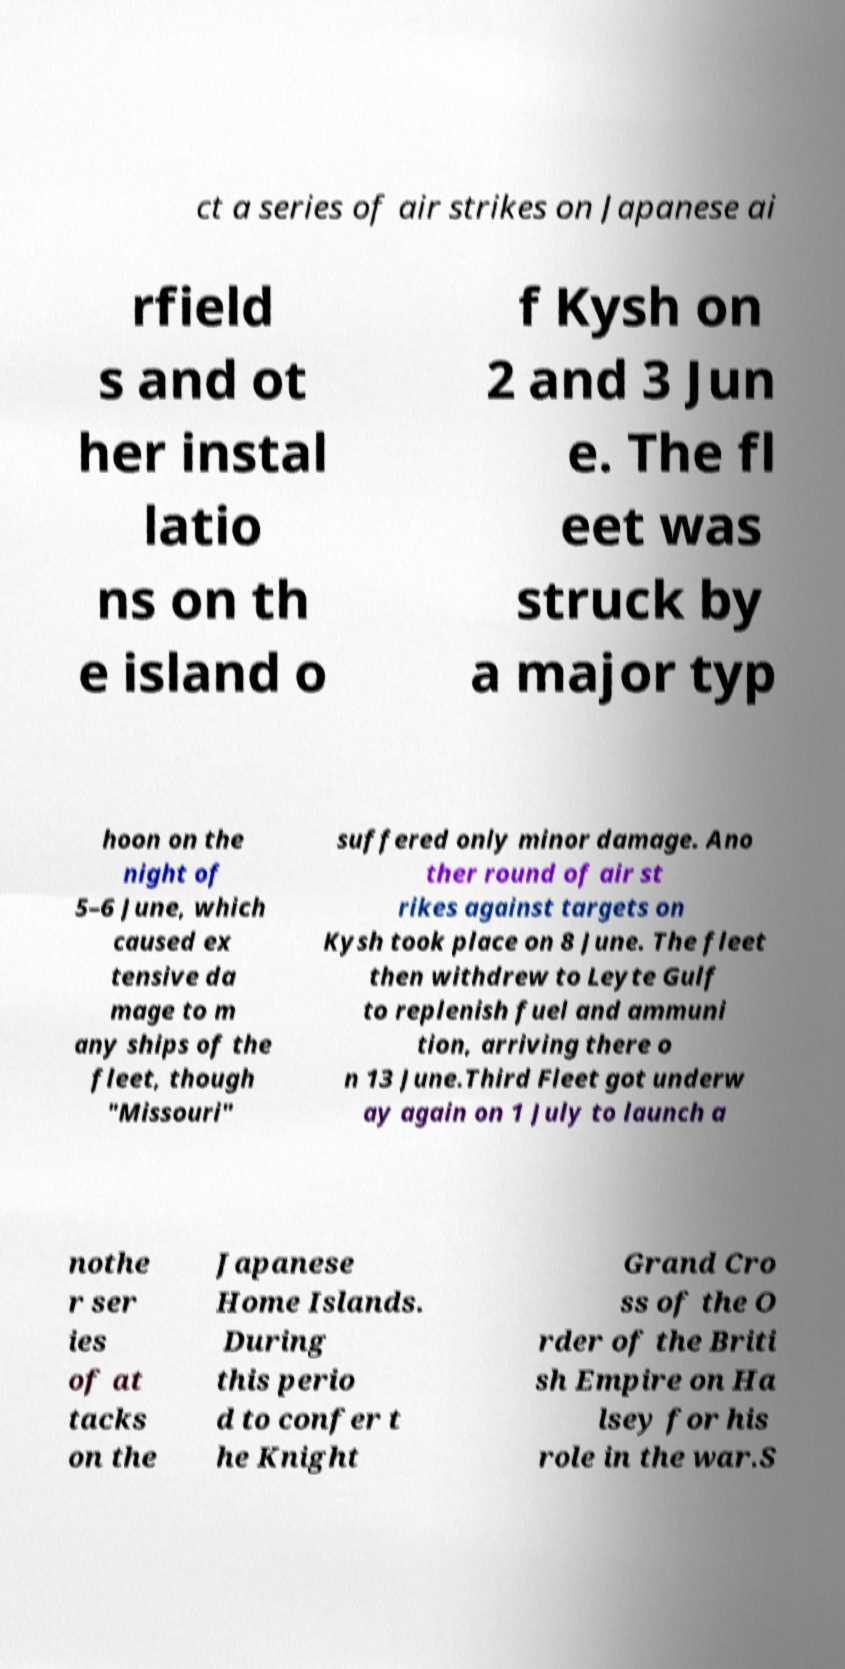Could you extract and type out the text from this image? ct a series of air strikes on Japanese ai rfield s and ot her instal latio ns on th e island o f Kysh on 2 and 3 Jun e. The fl eet was struck by a major typ hoon on the night of 5–6 June, which caused ex tensive da mage to m any ships of the fleet, though "Missouri" suffered only minor damage. Ano ther round of air st rikes against targets on Kysh took place on 8 June. The fleet then withdrew to Leyte Gulf to replenish fuel and ammuni tion, arriving there o n 13 June.Third Fleet got underw ay again on 1 July to launch a nothe r ser ies of at tacks on the Japanese Home Islands. During this perio d to confer t he Knight Grand Cro ss of the O rder of the Briti sh Empire on Ha lsey for his role in the war.S 